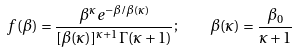Convert formula to latex. <formula><loc_0><loc_0><loc_500><loc_500>f ( \beta ) = \frac { \beta ^ { \kappa } e ^ { - \beta / \beta ( \kappa ) } } { [ \beta ( \kappa ) ] ^ { \kappa + 1 } \Gamma ( \kappa + 1 ) } ; \quad \beta ( \kappa ) = \frac { \beta _ { 0 } } { \kappa + 1 }</formula> 